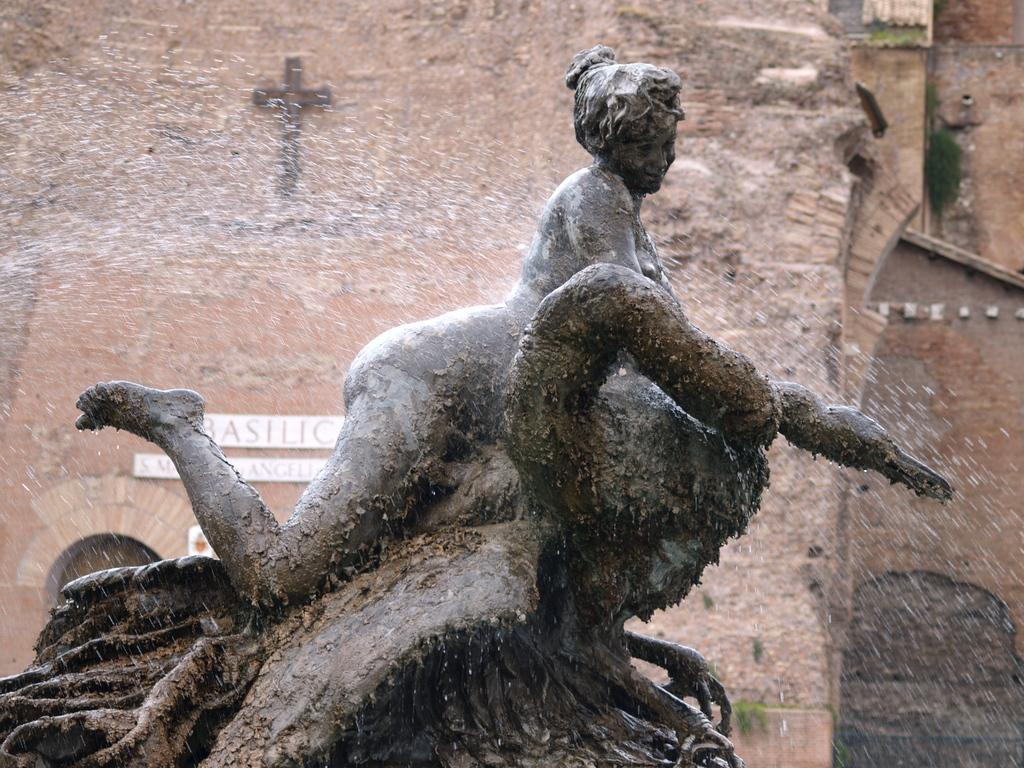What is the main subject of the image? There is a woman statue in the image. What is happening to the statue? Water is falling on the statue. What can be seen in the background of the image? There is a wall in the background of the image. What symbol is present on the wall? There is a holy cross mark on the wall. What type of bucket is being used to collect water from the statue? There is no bucket present in the image; water is falling on the statue. What organization is responsible for maintaining the statue and wall in the image? The image does not provide information about the organization responsible for maintaining the statue and wall. 